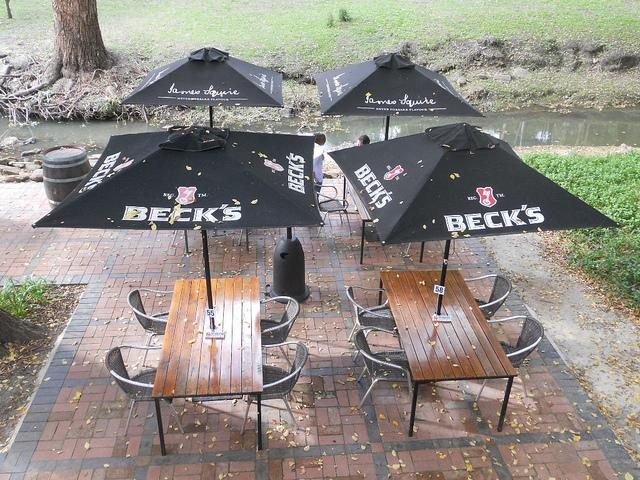What is this patio located next to?

Choices:
A) fountain
B) beach
C) stream
D) pool stream 